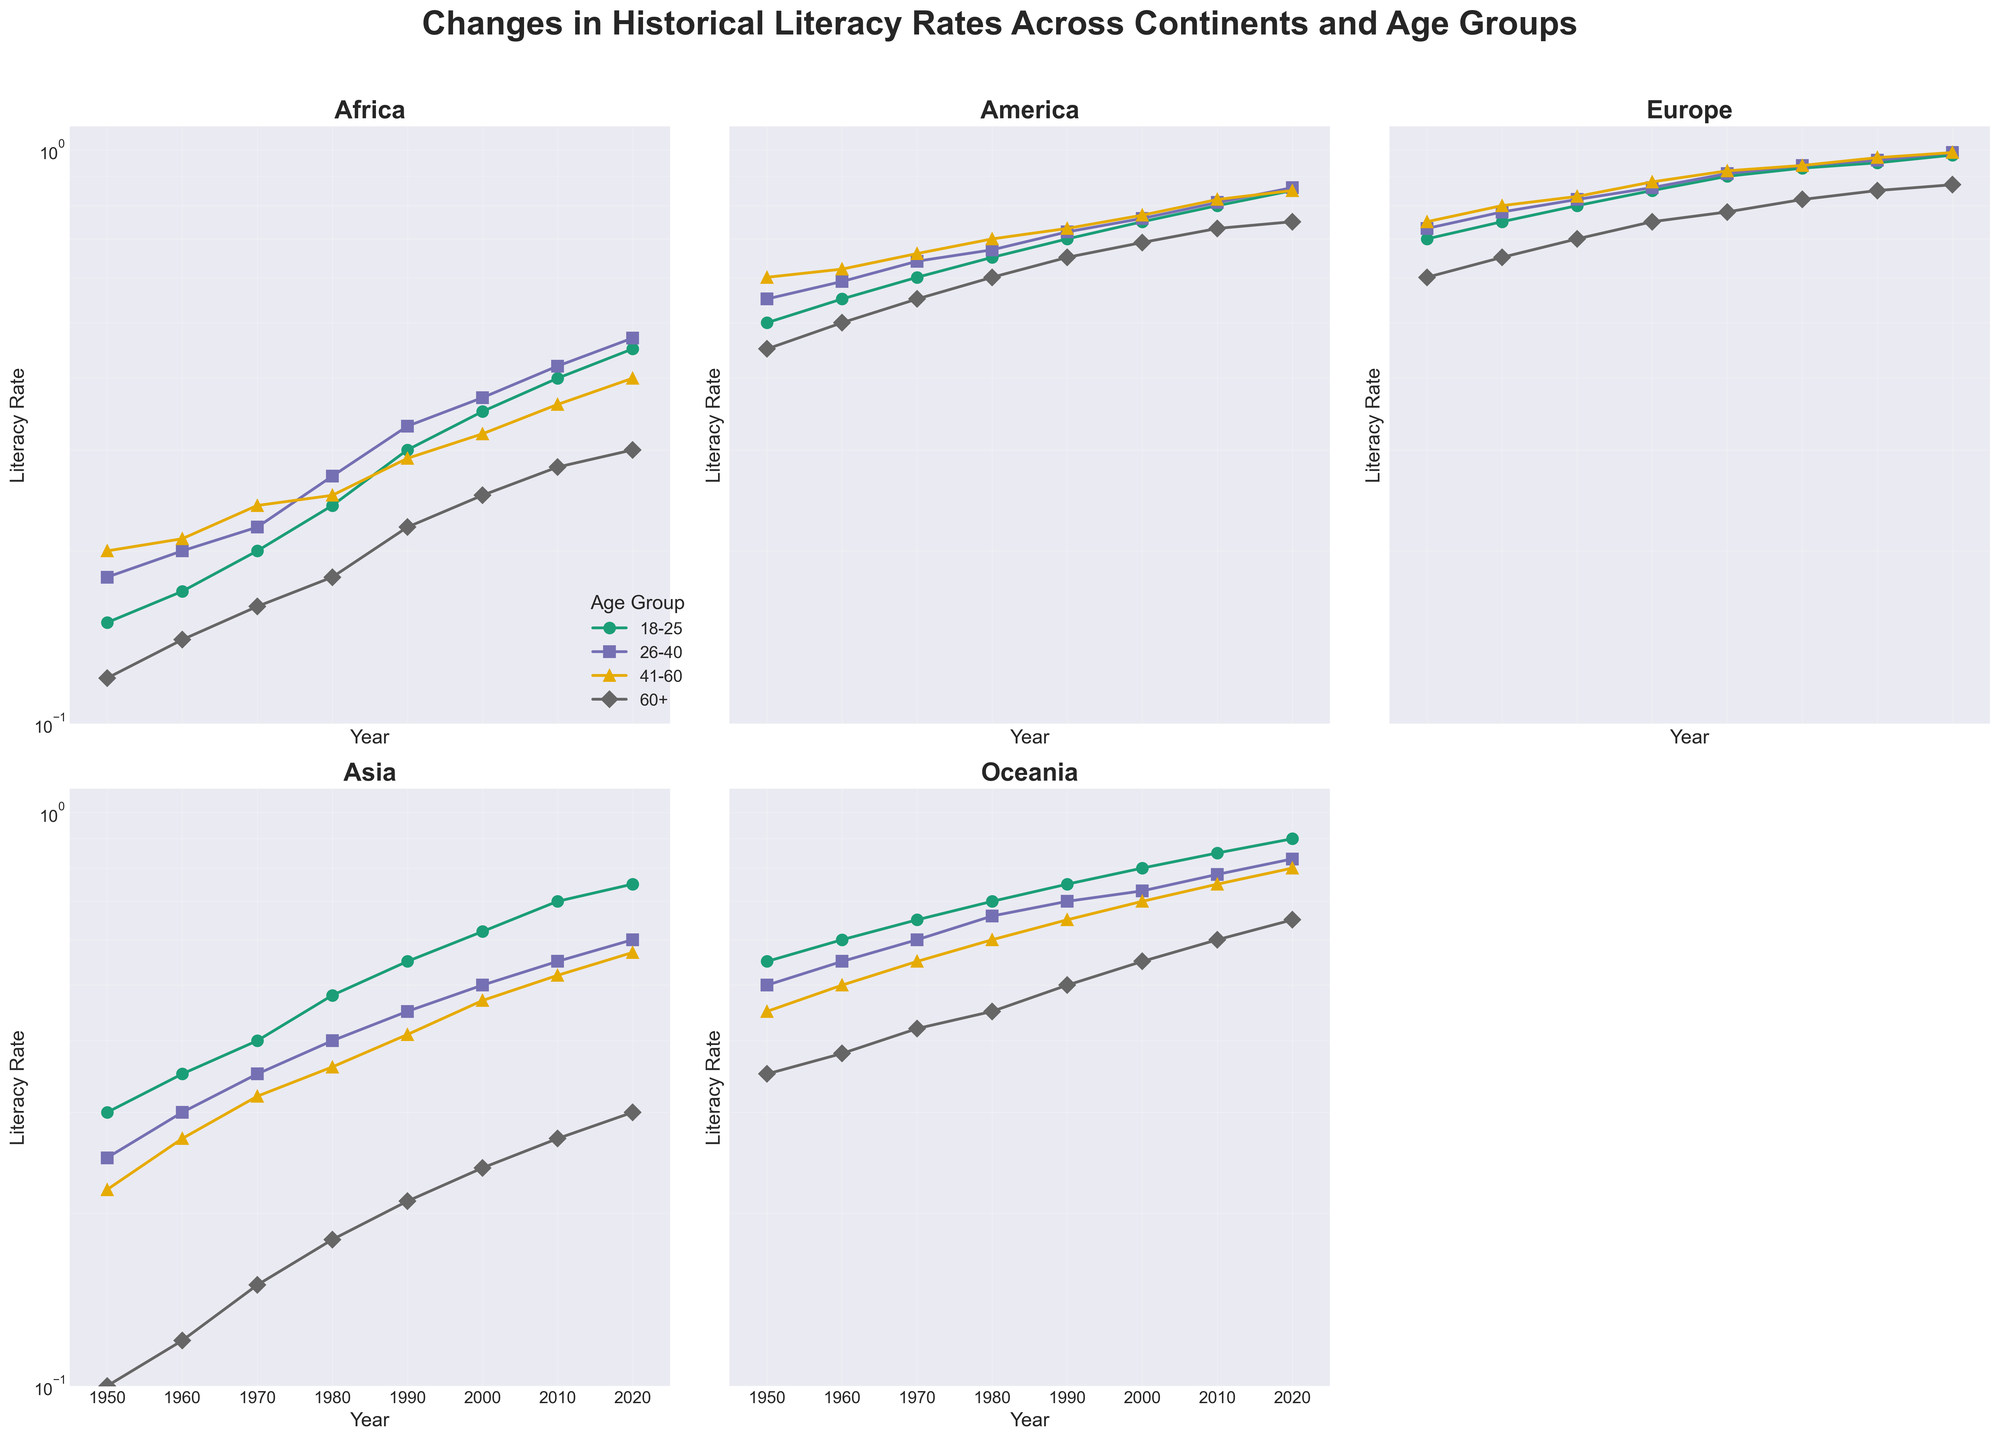What is the title of the figure? The title is generally located at the top of the figure. In the provided code, the title is set using the 'fig.suptitle' method.
Answer: "Changes in Historical Literacy Rates Across Continents and Age Groups" What time period does the figure cover? The x-axis represents the years, ranging from 1950 to 2020 as per the columns in the data. All subplots share this x-axis range.
Answer: 1950 to 2020 Which continent shows the highest literacy rates for the age group 18-25? One needs to visually compare the literacy rates represented by different markers for the '18-25' age group across all subplots. In the figure, Europe has the consistently highest literacy rates for this age group.
Answer: Europe How does the literacy rate for the 60+ age group in Africa in 2020 compare with that in Asia? Locate the 60+ age group in both regions in 2020 by looking at the subplot for Africa and Asia. Compare the end points. Africa's rate is 0.30 while Asia's rate is also 0.30.
Answer: Equal Which age group has the most significant growth in literacy rates in Africa from 1950 to 2020? Compare the starting and ending points of literacy rates for all age groups in Africa. Calculate the difference and find the age group with the highest value. The 18-25 age group shows an increase from 0.15 to 0.45.
Answer: 18-25 Are there any continents where the literacy rates for the 26-40 age group have surpassed 90% in 2020? Check the endpoint of the 26-40 age group series for all continents in 2020. None surpass 90%.
Answer: No Which age group in Europe had the lowest literacy rate in 1950? In the Europe subplot, find the series with the lowest starting point in 1950. The 60+ age group starts at 0.60.
Answer: 60+ Which continent shows less steep growth in literacy rates for the 41-60 age group? Compare the slopes of the 41-60 age group lines across continents (where the markers are '^'). The slope appears less steep in Oceania and Africa.
Answer: Africa What is the unique feature of the plot that helps display the literacy rates effectively? The plot uses a logarithmic scale (semilogy) on the y-axis, making it easier to compare rates that vary by orders of magnitude while showing smaller changes clearly.
Answer: Logarithmic scale 